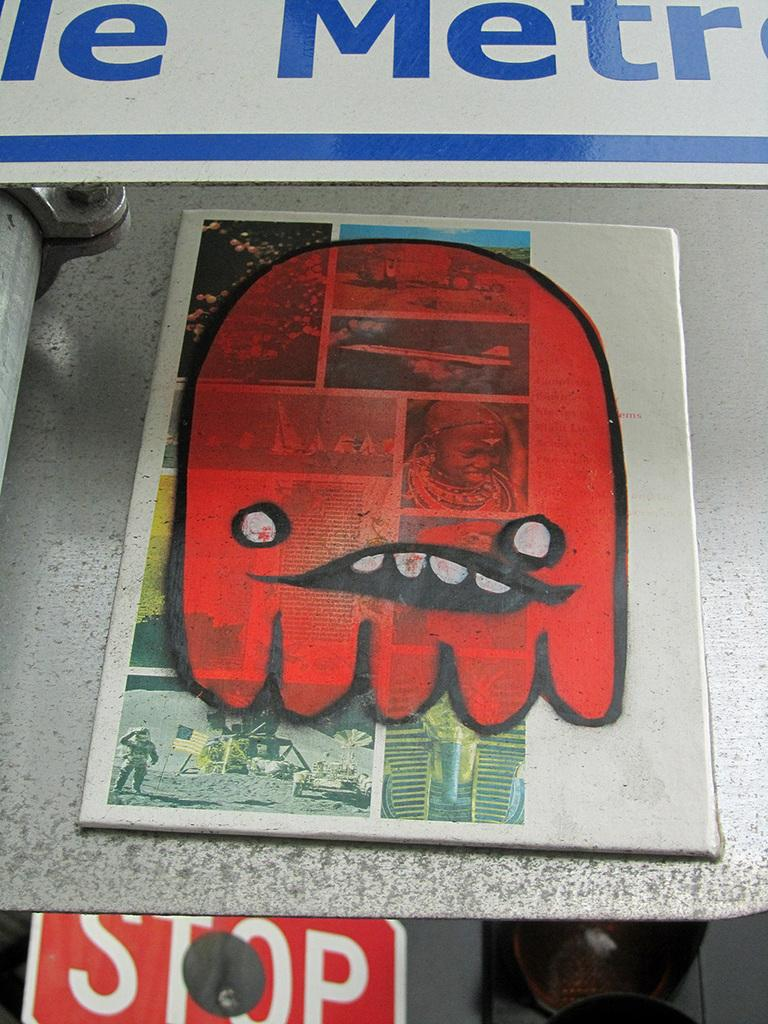What can be seen on the two boards in the image? The boards have text and photos on them. What are the boards placed on? The boards are placed on an object. What is located at the bottom of the image? There is a signboard and a traffic light at the bottom of the image. How many sisters are visible in the image? There are no sisters present in the image. What type of blade can be seen in the image? There is no blade present in the image. 